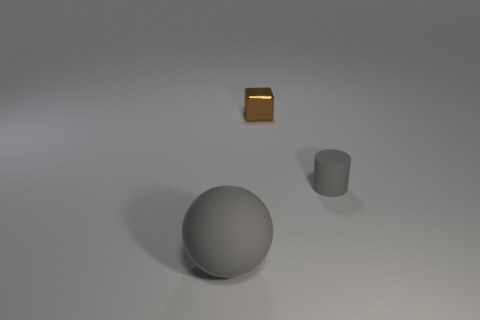What number of tiny cyan blocks have the same material as the gray cylinder?
Provide a succinct answer. 0. There is a large rubber thing; is it the same color as the rubber object behind the sphere?
Make the answer very short. Yes. What number of tiny cylinders are there?
Offer a very short reply. 1. Are there any rubber objects that have the same color as the rubber cylinder?
Keep it short and to the point. Yes. What is the color of the rubber object behind the matte thing to the left of the gray matte object behind the large matte ball?
Offer a very short reply. Gray. Is the tiny brown thing made of the same material as the gray object that is left of the gray matte cylinder?
Make the answer very short. No. What is the small brown block made of?
Give a very brief answer. Metal. How many other things are there of the same material as the tiny gray thing?
Your answer should be compact. 1. What is the shape of the object that is both to the left of the gray rubber cylinder and in front of the metallic thing?
Keep it short and to the point. Sphere. There is a sphere that is the same material as the tiny cylinder; what is its color?
Your answer should be compact. Gray. 